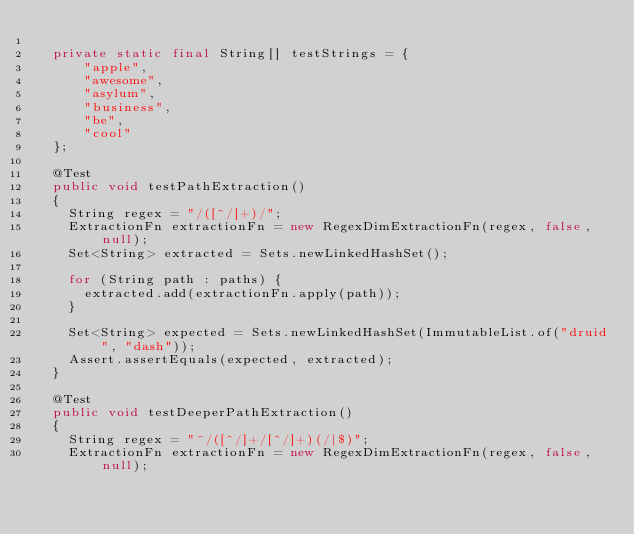Convert code to text. <code><loc_0><loc_0><loc_500><loc_500><_Java_>
  private static final String[] testStrings = {
      "apple",
      "awesome",
      "asylum",
      "business",
      "be",
      "cool"
  };

  @Test
  public void testPathExtraction()
  {
    String regex = "/([^/]+)/";
    ExtractionFn extractionFn = new RegexDimExtractionFn(regex, false, null);
    Set<String> extracted = Sets.newLinkedHashSet();

    for (String path : paths) {
      extracted.add(extractionFn.apply(path));
    }

    Set<String> expected = Sets.newLinkedHashSet(ImmutableList.of("druid", "dash"));
    Assert.assertEquals(expected, extracted);
  }

  @Test
  public void testDeeperPathExtraction()
  {
    String regex = "^/([^/]+/[^/]+)(/|$)";
    ExtractionFn extractionFn = new RegexDimExtractionFn(regex, false, null);</code> 